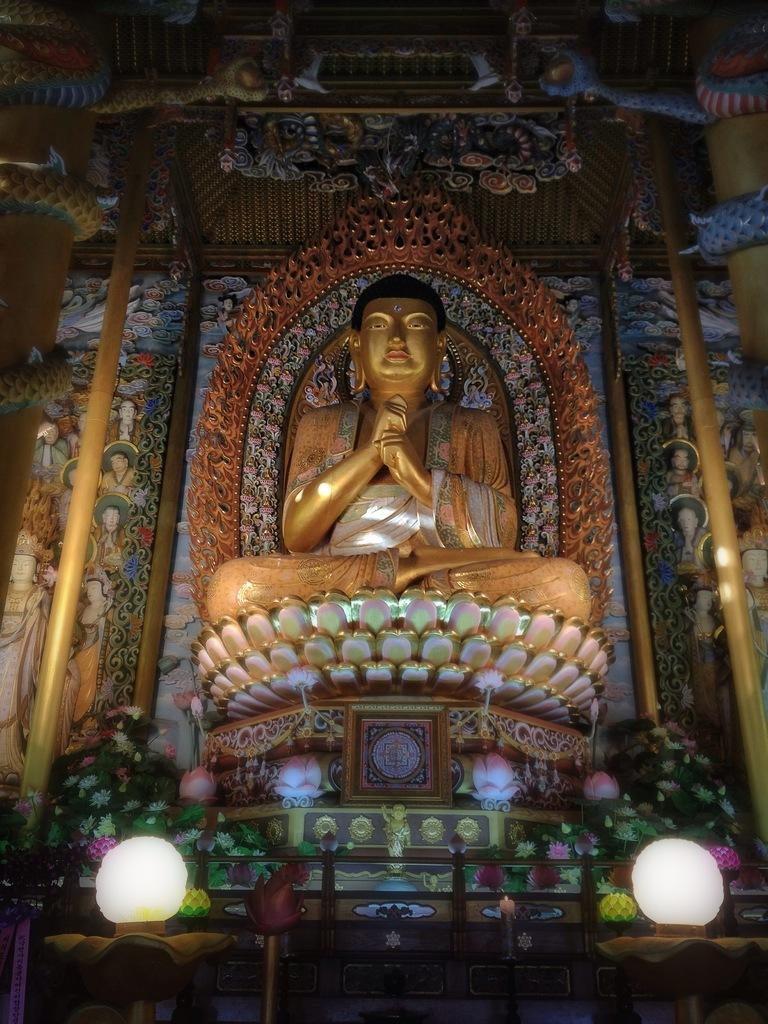Describe this image in one or two sentences. In this picture we can see a statue of Buddha, at the bottom there are two lights, we can see some flowers and leaves here. 